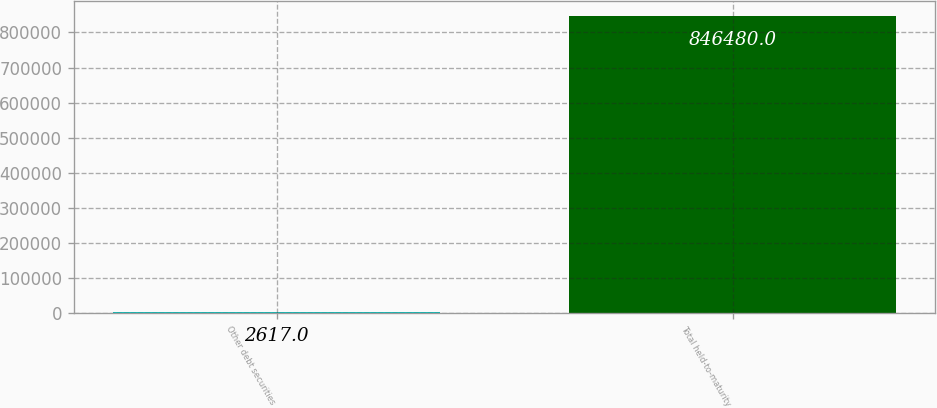<chart> <loc_0><loc_0><loc_500><loc_500><bar_chart><fcel>Other debt securities<fcel>Total held-to-maturity<nl><fcel>2617<fcel>846480<nl></chart> 